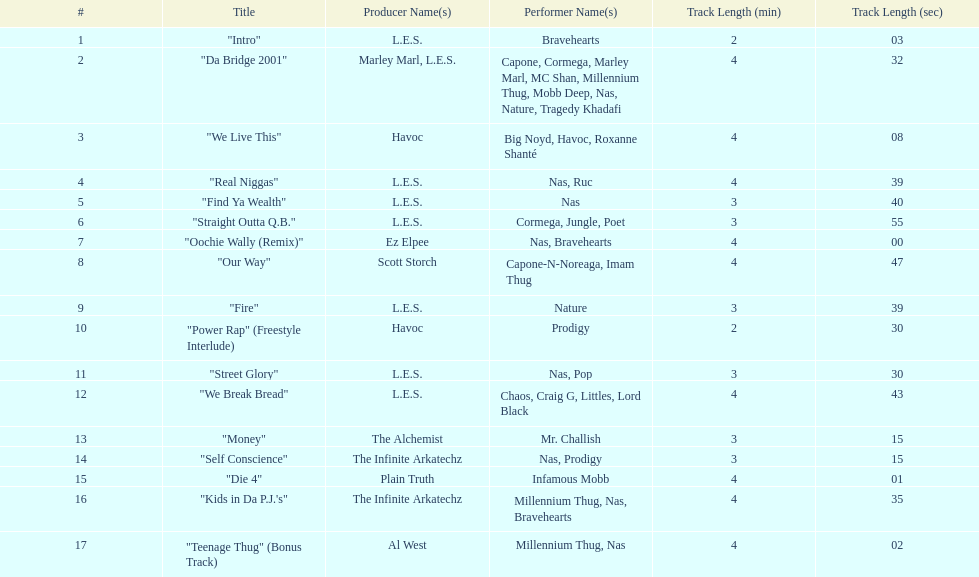What is the first song on the album produced by havoc? "We Live This". 